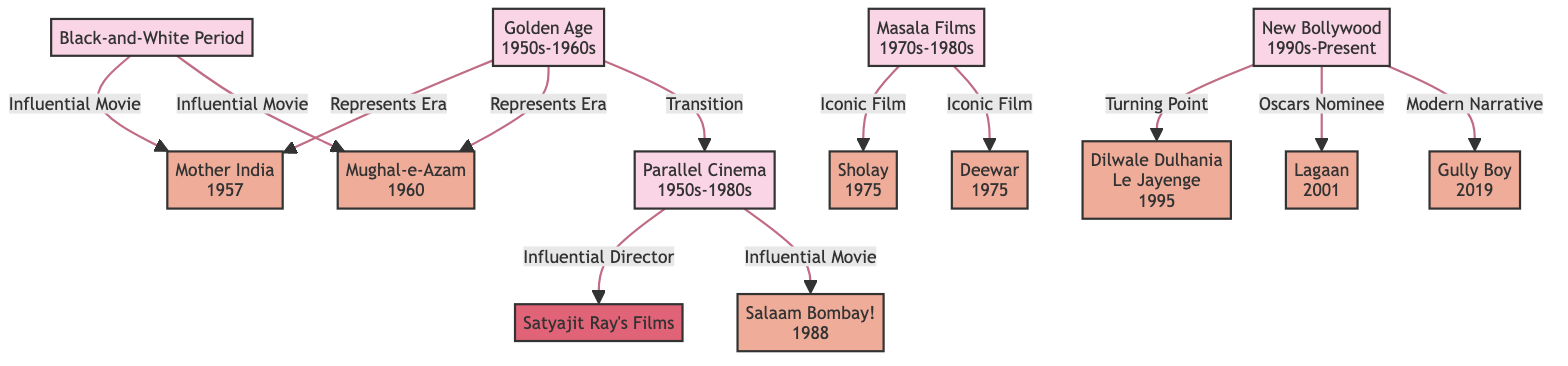What era does "Mother India" represent? The diagram indicates that "Mother India" is linked to the "Golden Age" node with a label "Represents Era," meaning "Mother India" is associated with this period.
Answer: Golden Age (1950s-1960s) How many influential movies are connected to the black-and-white period? The black-and-white period connects to two movies: "Mother India" and "Mughal-e-Azam," indicating there are two influential movies from this period.
Answer: 2 Which movie marks the turning point in New Bollywood? According to the diagram, "Dilwale Dulhania Le Jayenge" is identified as the turning point, highlighted as "Turning Point" connected to the "New Bollywood" era.
Answer: Dilwale Dulhania Le Jayenge (1995) What is the connection between "Parallel Cinema" and "Satyajit Ray's Films"? The diagram shows a direct link from "Parallel Cinema" to "Satyajit Ray's Films" labeled "Influential Director," indicating Satyajit Ray is an important figure in this genre.
Answer: Influential Director Which iconic films are associated with Masala Films? The diagram lists "Sholay" and "Deewar" specifically linked to "Masala Films" with the label "Iconic Film," demonstrating their significance within this genre.
Answer: Sholay, Deewar 